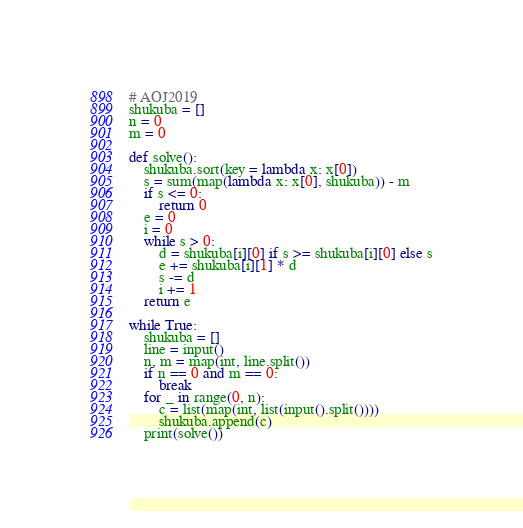<code> <loc_0><loc_0><loc_500><loc_500><_Python_># AOJ2019
shukuba = []
n = 0
m = 0

def solve():
    shukuba.sort(key = lambda x: x[0])
    s = sum(map(lambda x: x[0], shukuba)) - m
    if s <= 0:
        return 0
    e = 0
    i = 0
    while s > 0:
        d = shukuba[i][0] if s >= shukuba[i][0] else s
        e += shukuba[i][1] * d
        s -= d
        i += 1
    return e

while True:
    shukuba = []
    line = input()
    n, m = map(int, line.split())
    if n == 0 and m == 0:
        break
    for _ in range(0, n):
        c = list(map(int, list(input().split())))
        shukuba.append(c)
    print(solve())
</code> 